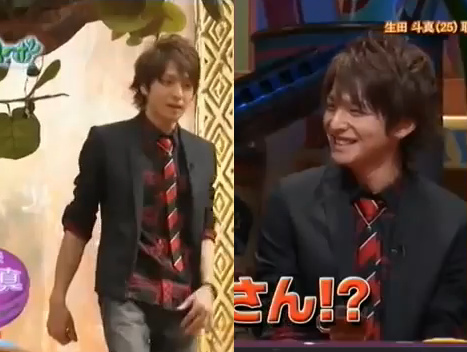Imagine if this image were a scene from a movie. What could be the plot? In a movie, this scene could depict a pivotal moment in a coming-of-age story. The young man, having been invited to a prestigious event, finds himself under the spotlight for his outstanding achievements. This interaction could be with a renowned mentor or a celebrity host, as they discuss his journey, challenges, and triumphs. The setting exudes a mixture of excitement and nervousness, as the young man prepares to address both his past and future endeavors. 